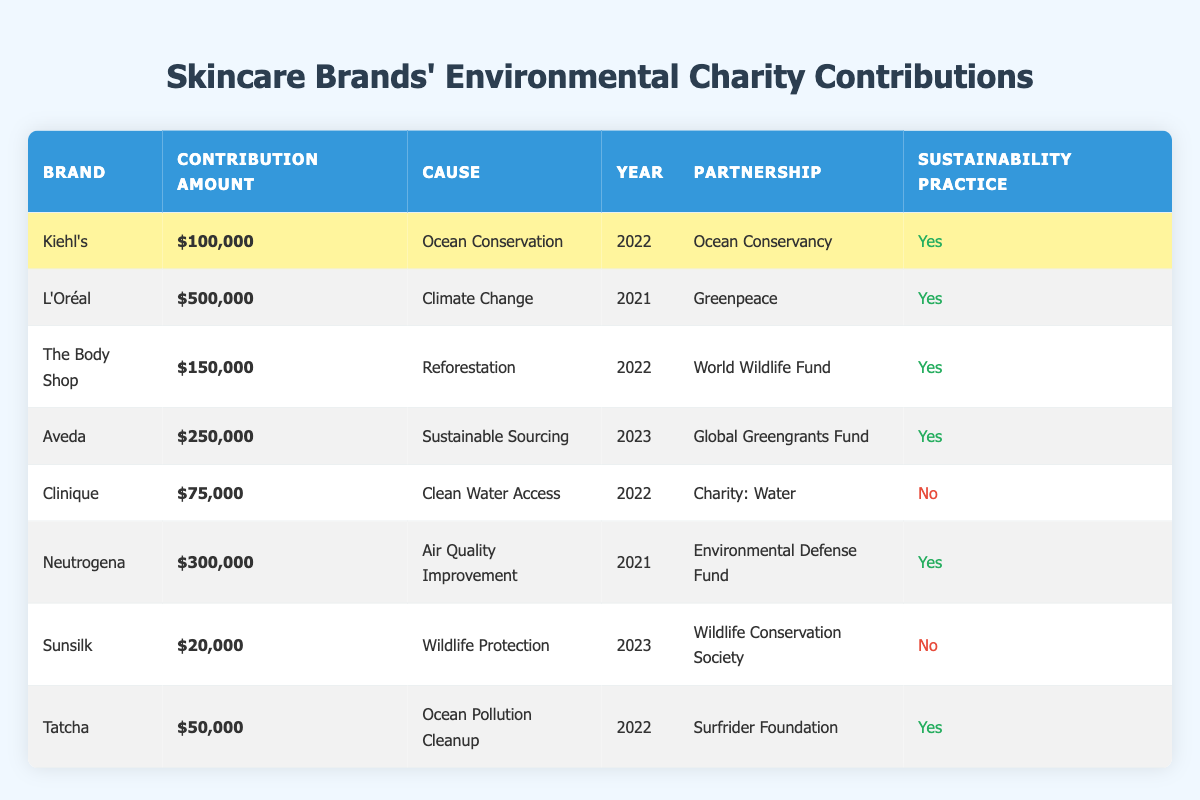What is Kiehl's contribution amount for Ocean Conservation? The table indicates that Kiehl's contribution amount for Ocean Conservation was $100,000 in the year 2022. This can be found by looking at the respective row under the "Contribution Amount" column for Kiehl's.
Answer: 100000 Which brand contributed the most to environmental causes? By reviewing the contribution amounts for all brands listed, L'Oréal contributed the most, with a total of $500,000 for the cause of Climate Change in 2021. This is the highest value in the "Contribution Amount" column.
Answer: L'Oréal How many brands have sustainability practices listed as true? The brands with sustainability practices listed as true are Kiehl's, L'Oréal, The Body Shop, Aveda, Neutrogena, and Tatcha. Counting these brands gives us a total of 6, as these are the ones marked with "Yes" in the "Sustainability Practice" column.
Answer: 6 What is the sum of contributions for brands with sustainable practices? To find the total contributions, we add Kiehl's ($100,000), L'Oréal ($500,000), The Body Shop ($150,000), Aveda ($250,000), Neutrogena ($300,000), and Tatcha ($50,000). The total is calculated as follows: 100000 + 500000 + 150000 + 250000 + 300000 + 50000 = $1,350,000.
Answer: 1350000 Did Clinique have a partnership for a sustainable cause? Referring to the table, Clinique had a partnership with Charity: Water for Clean Water Access, but its sustainability practice is marked as false. Thus, the answer is no. This can be confirmed by checking the "Sustainability Practice" column for Clinique, which indicates "No."
Answer: No What environmental causes were supported by brands in 2022? The brands that supported environmental causes in 2022 are Kiehl's, The Body Shop, and Clinique. Kiehl's contributed to Ocean Conservation, The Body Shop to Reforestation, and Clinique focused on Clean Water Access. Thus, those are the causes listed under the "Cause" column for the year 2022.
Answer: Ocean Conservation, Reforestation, Clean Water Access How many brands contributed to causes related to ocean conservation? Looking at the table, Kiehl's and Tatcha are the two brands that contributed to ocean-related causes: Kiehl's supported Ocean Conservation, and Tatcha was involved in Ocean Pollution Cleanup. Counting these leads us to a total of 2 brands.
Answer: 2 What percentage of total contributions were made by Neutrogena? To calculate this, first, we find Neutrogena's contribution of $300,000. Then we calculate the total contributions, which is $1,350,000 from the previous question. The percentage is calculated as (300000 / 1350000) * 100 = 22.22%.
Answer: 22.22% 